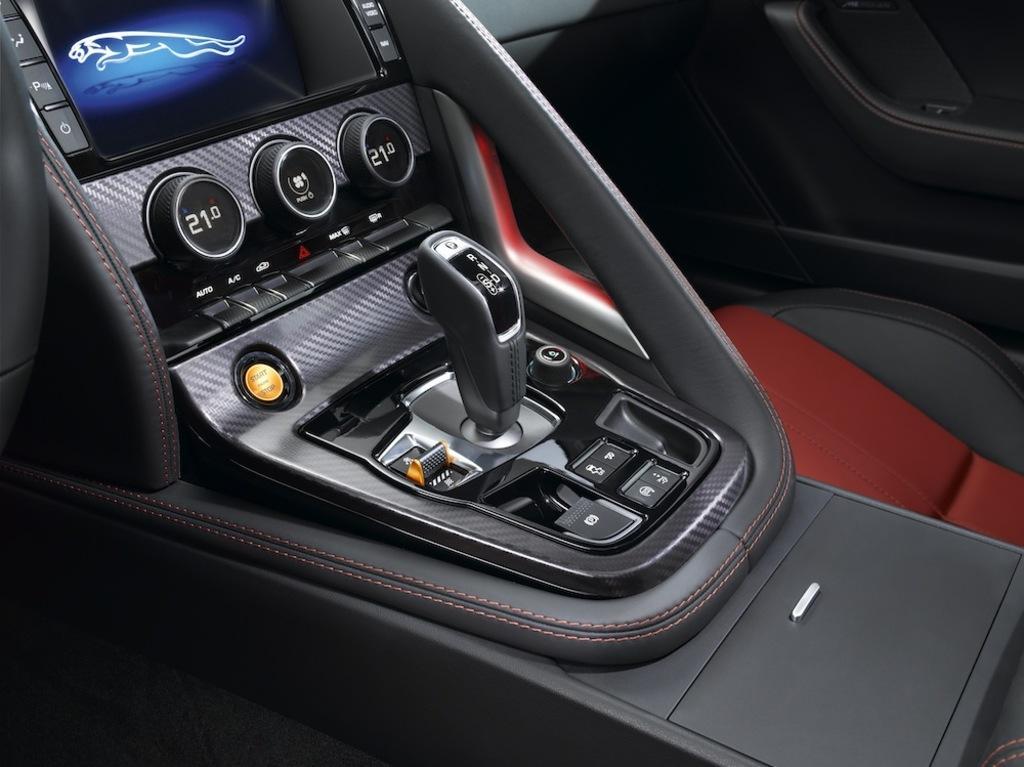Describe this image in one or two sentences. In this image we can see an inside view of a car, there is a screen, there is a seat towards the right of the image, there are buttons, there is a gear stick, there's the door towards the top of the image, there is an object towards the left of the image. 